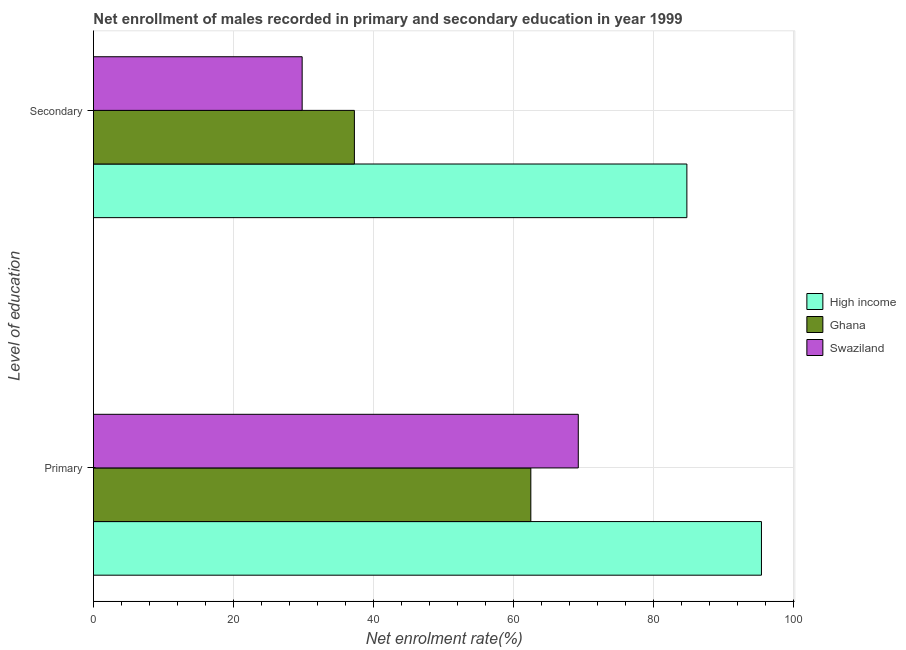How many different coloured bars are there?
Offer a terse response. 3. How many groups of bars are there?
Ensure brevity in your answer.  2. What is the label of the 2nd group of bars from the top?
Keep it short and to the point. Primary. What is the enrollment rate in primary education in High income?
Keep it short and to the point. 95.41. Across all countries, what is the maximum enrollment rate in primary education?
Your response must be concise. 95.41. Across all countries, what is the minimum enrollment rate in secondary education?
Offer a terse response. 29.81. In which country was the enrollment rate in secondary education maximum?
Offer a very short reply. High income. In which country was the enrollment rate in primary education minimum?
Keep it short and to the point. Ghana. What is the total enrollment rate in primary education in the graph?
Provide a succinct answer. 227.12. What is the difference between the enrollment rate in primary education in Swaziland and that in High income?
Provide a succinct answer. -26.16. What is the difference between the enrollment rate in primary education in Ghana and the enrollment rate in secondary education in Swaziland?
Give a very brief answer. 32.66. What is the average enrollment rate in primary education per country?
Keep it short and to the point. 75.71. What is the difference between the enrollment rate in primary education and enrollment rate in secondary education in Ghana?
Offer a very short reply. 25.2. In how many countries, is the enrollment rate in primary education greater than 84 %?
Give a very brief answer. 1. What is the ratio of the enrollment rate in primary education in High income to that in Swaziland?
Provide a succinct answer. 1.38. Is the enrollment rate in primary education in High income less than that in Swaziland?
Your response must be concise. No. In how many countries, is the enrollment rate in primary education greater than the average enrollment rate in primary education taken over all countries?
Provide a short and direct response. 1. How many bars are there?
Provide a succinct answer. 6. Are all the bars in the graph horizontal?
Your response must be concise. Yes. Are the values on the major ticks of X-axis written in scientific E-notation?
Make the answer very short. No. How are the legend labels stacked?
Your response must be concise. Vertical. What is the title of the graph?
Offer a terse response. Net enrollment of males recorded in primary and secondary education in year 1999. What is the label or title of the X-axis?
Provide a succinct answer. Net enrolment rate(%). What is the label or title of the Y-axis?
Ensure brevity in your answer.  Level of education. What is the Net enrolment rate(%) of High income in Primary?
Offer a terse response. 95.41. What is the Net enrolment rate(%) in Ghana in Primary?
Ensure brevity in your answer.  62.47. What is the Net enrolment rate(%) of Swaziland in Primary?
Give a very brief answer. 69.24. What is the Net enrolment rate(%) in High income in Secondary?
Your response must be concise. 84.75. What is the Net enrolment rate(%) in Ghana in Secondary?
Ensure brevity in your answer.  37.27. What is the Net enrolment rate(%) of Swaziland in Secondary?
Make the answer very short. 29.81. Across all Level of education, what is the maximum Net enrolment rate(%) of High income?
Your response must be concise. 95.41. Across all Level of education, what is the maximum Net enrolment rate(%) in Ghana?
Provide a succinct answer. 62.47. Across all Level of education, what is the maximum Net enrolment rate(%) in Swaziland?
Provide a succinct answer. 69.24. Across all Level of education, what is the minimum Net enrolment rate(%) in High income?
Keep it short and to the point. 84.75. Across all Level of education, what is the minimum Net enrolment rate(%) of Ghana?
Your answer should be very brief. 37.27. Across all Level of education, what is the minimum Net enrolment rate(%) of Swaziland?
Provide a short and direct response. 29.81. What is the total Net enrolment rate(%) in High income in the graph?
Give a very brief answer. 180.16. What is the total Net enrolment rate(%) in Ghana in the graph?
Offer a terse response. 99.74. What is the total Net enrolment rate(%) of Swaziland in the graph?
Your answer should be compact. 99.05. What is the difference between the Net enrolment rate(%) of High income in Primary and that in Secondary?
Give a very brief answer. 10.65. What is the difference between the Net enrolment rate(%) in Ghana in Primary and that in Secondary?
Your answer should be very brief. 25.2. What is the difference between the Net enrolment rate(%) in Swaziland in Primary and that in Secondary?
Offer a terse response. 39.44. What is the difference between the Net enrolment rate(%) in High income in Primary and the Net enrolment rate(%) in Ghana in Secondary?
Provide a short and direct response. 58.14. What is the difference between the Net enrolment rate(%) in High income in Primary and the Net enrolment rate(%) in Swaziland in Secondary?
Provide a short and direct response. 65.6. What is the difference between the Net enrolment rate(%) in Ghana in Primary and the Net enrolment rate(%) in Swaziland in Secondary?
Ensure brevity in your answer.  32.66. What is the average Net enrolment rate(%) of High income per Level of education?
Keep it short and to the point. 90.08. What is the average Net enrolment rate(%) in Ghana per Level of education?
Make the answer very short. 49.87. What is the average Net enrolment rate(%) of Swaziland per Level of education?
Your answer should be very brief. 49.52. What is the difference between the Net enrolment rate(%) in High income and Net enrolment rate(%) in Ghana in Primary?
Offer a very short reply. 32.94. What is the difference between the Net enrolment rate(%) in High income and Net enrolment rate(%) in Swaziland in Primary?
Offer a very short reply. 26.16. What is the difference between the Net enrolment rate(%) of Ghana and Net enrolment rate(%) of Swaziland in Primary?
Make the answer very short. -6.78. What is the difference between the Net enrolment rate(%) of High income and Net enrolment rate(%) of Ghana in Secondary?
Provide a short and direct response. 47.49. What is the difference between the Net enrolment rate(%) in High income and Net enrolment rate(%) in Swaziland in Secondary?
Ensure brevity in your answer.  54.95. What is the difference between the Net enrolment rate(%) in Ghana and Net enrolment rate(%) in Swaziland in Secondary?
Provide a succinct answer. 7.46. What is the ratio of the Net enrolment rate(%) of High income in Primary to that in Secondary?
Provide a succinct answer. 1.13. What is the ratio of the Net enrolment rate(%) of Ghana in Primary to that in Secondary?
Make the answer very short. 1.68. What is the ratio of the Net enrolment rate(%) of Swaziland in Primary to that in Secondary?
Make the answer very short. 2.32. What is the difference between the highest and the second highest Net enrolment rate(%) of High income?
Your answer should be very brief. 10.65. What is the difference between the highest and the second highest Net enrolment rate(%) in Ghana?
Offer a terse response. 25.2. What is the difference between the highest and the second highest Net enrolment rate(%) in Swaziland?
Make the answer very short. 39.44. What is the difference between the highest and the lowest Net enrolment rate(%) of High income?
Your response must be concise. 10.65. What is the difference between the highest and the lowest Net enrolment rate(%) of Ghana?
Keep it short and to the point. 25.2. What is the difference between the highest and the lowest Net enrolment rate(%) of Swaziland?
Provide a short and direct response. 39.44. 